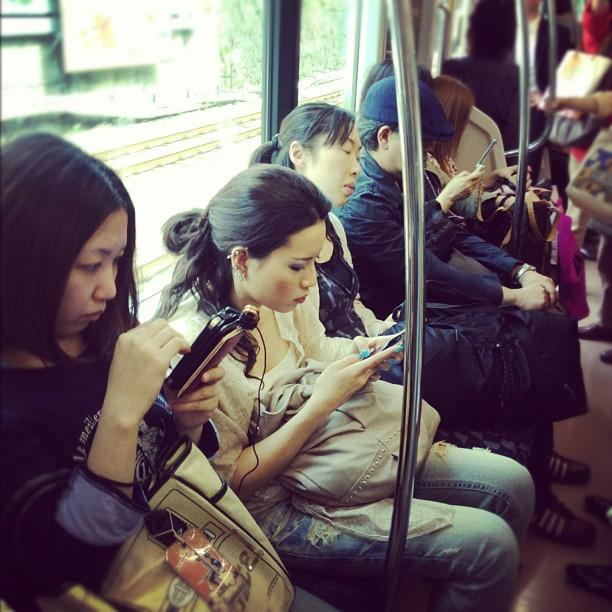If one was standing what would assist in maintaining their balance? Please explain your reasoning. pole. The pole allows people to hold on for balance. 